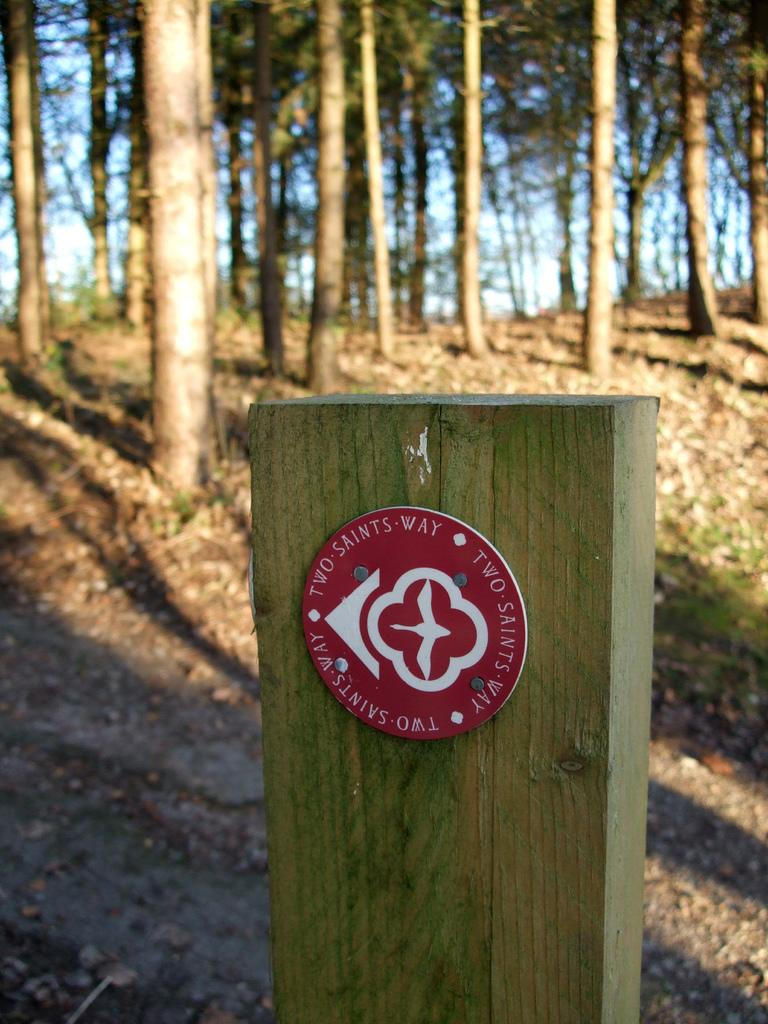What is located in the center of the image? There is a wood in the center of the image. What can be seen in the background of the image? There are trees and the sky visible in the background of the image. What is visible on the ground in the image? The ground is visible in the background of the image. Can you see any lines or patterns on the wood in the image? There is no mention of lines or patterns on the wood in the image. Are there any chickens visible in the image? There is no mention of chickens in the image. Can you hear any crying sounds in the image? Images are silent, so there are no crying sounds in the image. 